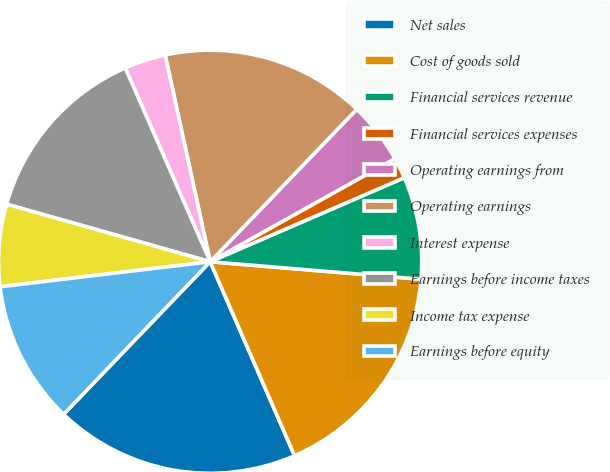<chart> <loc_0><loc_0><loc_500><loc_500><pie_chart><fcel>Net sales<fcel>Cost of goods sold<fcel>Financial services revenue<fcel>Financial services expenses<fcel>Operating earnings from<fcel>Operating earnings<fcel>Interest expense<fcel>Earnings before income taxes<fcel>Income tax expense<fcel>Earnings before equity<nl><fcel>18.71%<fcel>17.15%<fcel>7.82%<fcel>1.6%<fcel>4.71%<fcel>15.6%<fcel>3.16%<fcel>14.04%<fcel>6.27%<fcel>10.93%<nl></chart> 